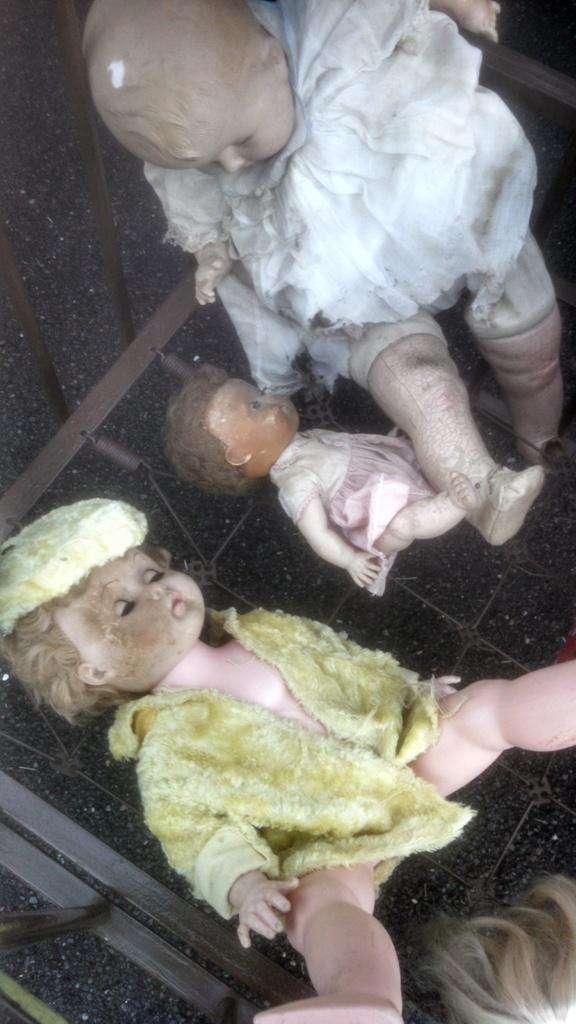Please provide a concise description of this image. In this image we can see some dolls. We can also see some metal poles. 